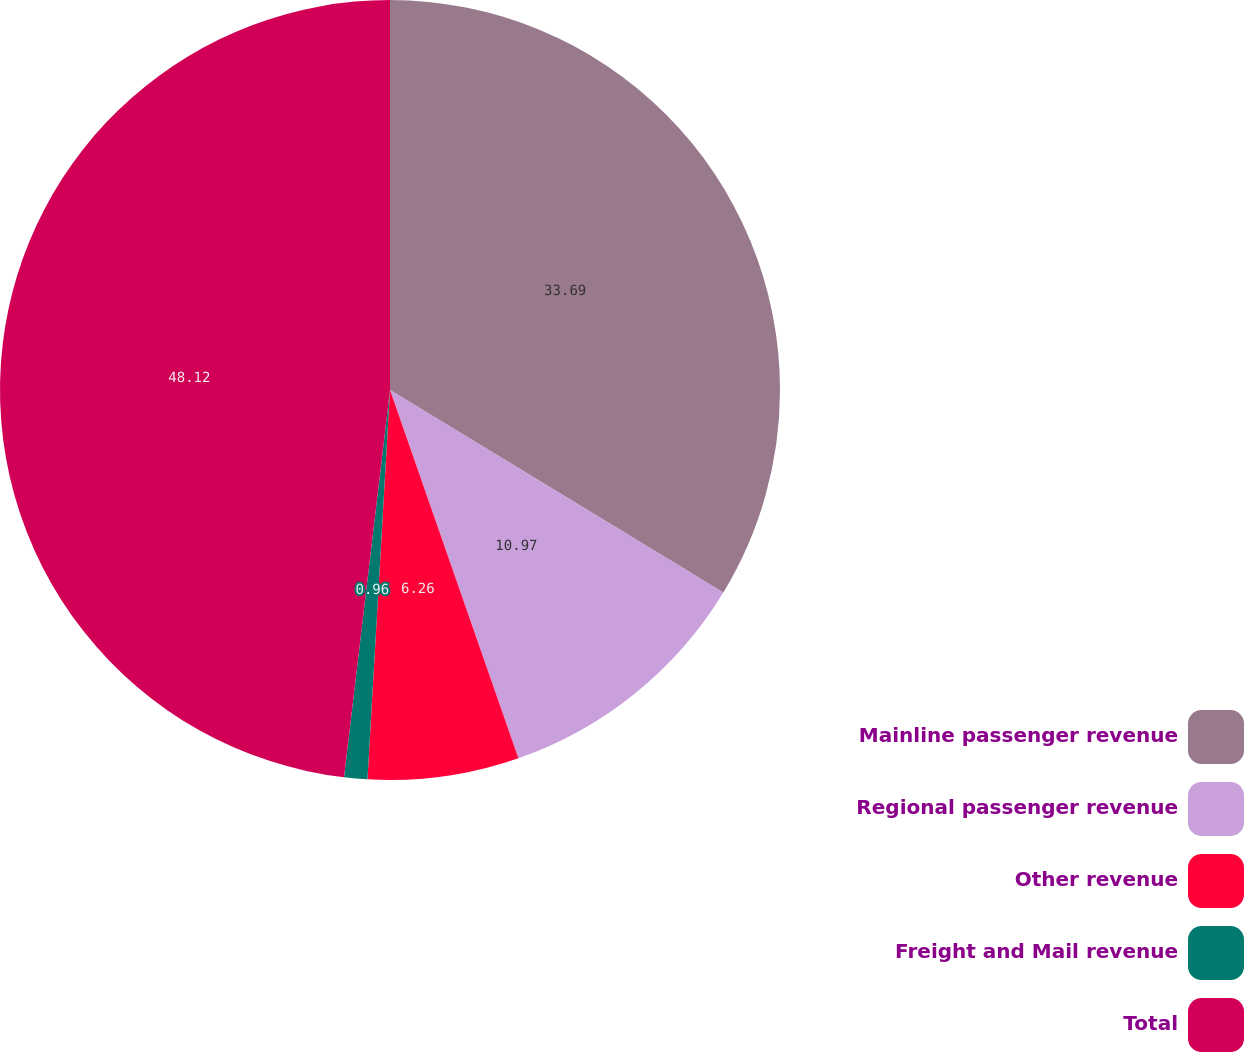Convert chart. <chart><loc_0><loc_0><loc_500><loc_500><pie_chart><fcel>Mainline passenger revenue<fcel>Regional passenger revenue<fcel>Other revenue<fcel>Freight and Mail revenue<fcel>Total<nl><fcel>33.69%<fcel>10.97%<fcel>6.26%<fcel>0.96%<fcel>48.12%<nl></chart> 